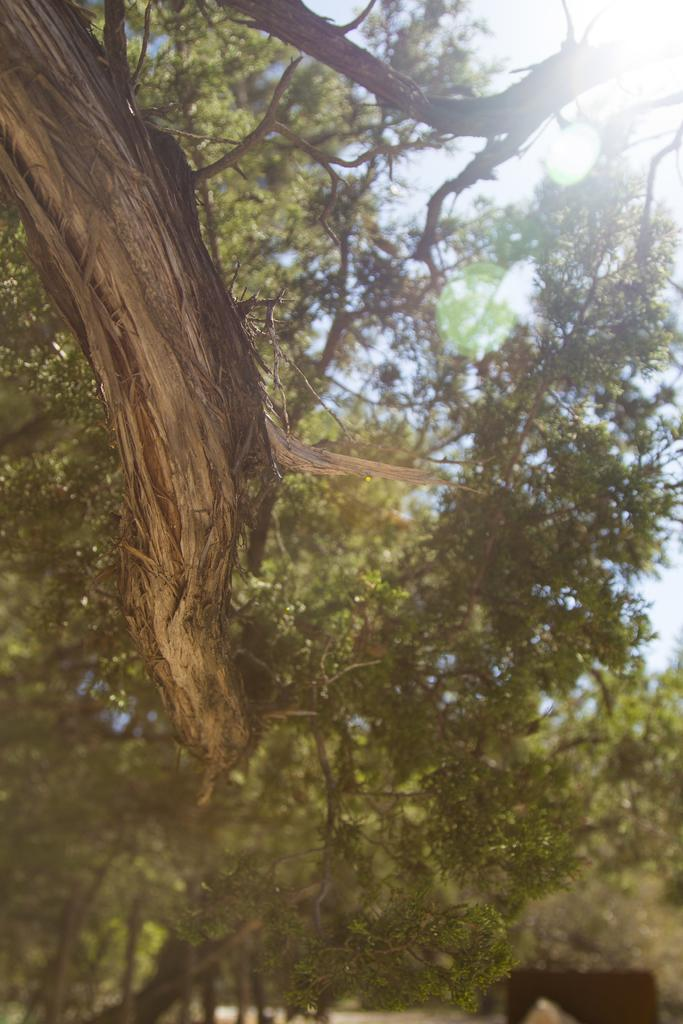What type of vegetation is visible in the image? There are many trees in the image. What is the weather condition in the image? There is bright sunshine in the image. What type of belief system is being practiced by the tiger in the image? There is no tiger present in the image, so it is not possible to determine what belief system might be practiced. 